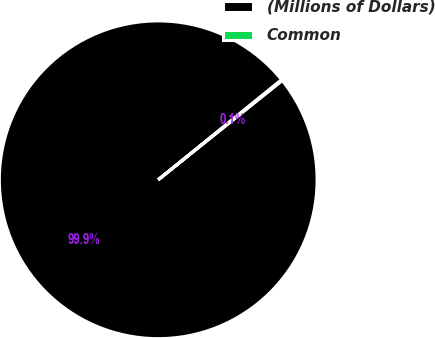<chart> <loc_0><loc_0><loc_500><loc_500><pie_chart><fcel>(Millions of Dollars)<fcel>Common<nl><fcel>99.9%<fcel>0.1%<nl></chart> 